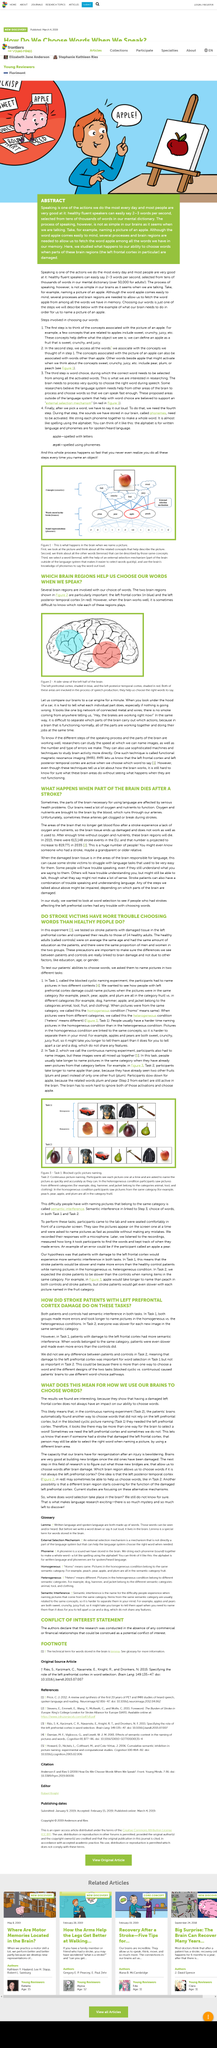Mention a couple of crucial points in this snapshot. Hetero" means "different" in this context. The posterior temporal cortex is the cotex that is represented as being lower in the brain. Phonemes are the sounds that are stored in the brain and are the building blocks of language. The word for the "external selection mechanism" in figure one is "apple. In order to determine the function of a part of the brain, we can compare the activity in that region when there is a problem to the activity in the same region when there is no problem, as shown by comparing problem-related fMRI results to brain scans without the problem. 